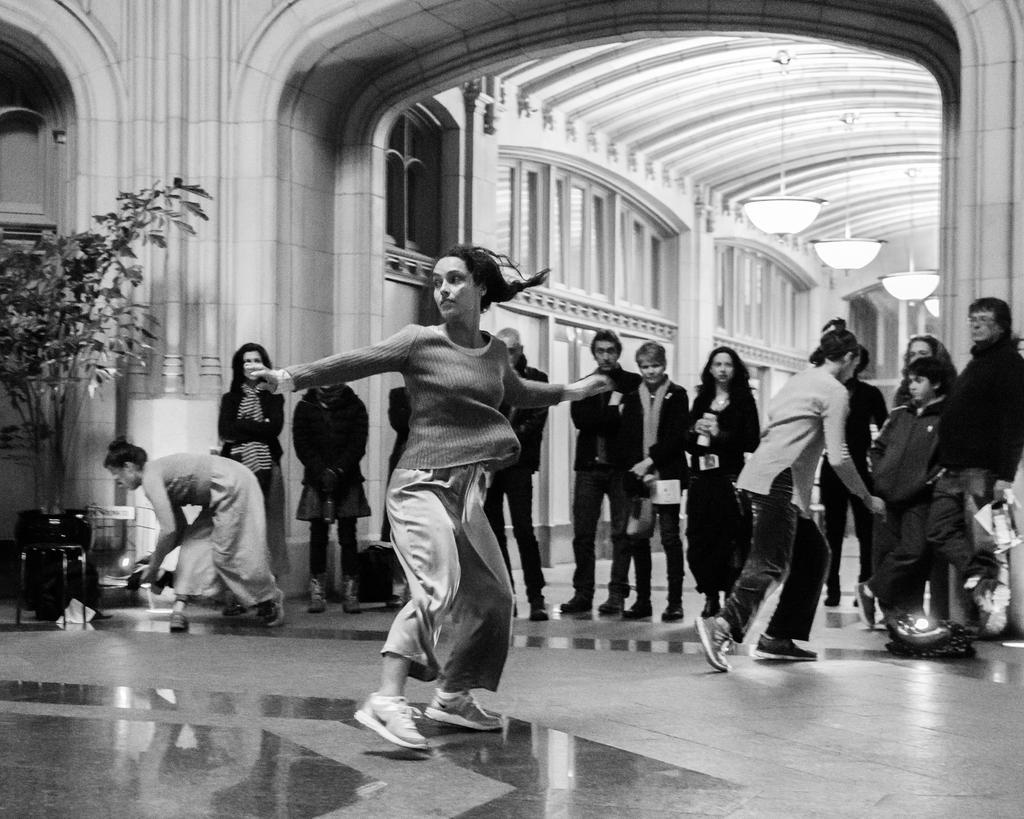How would you summarize this image in a sentence or two? In this image I can see a group of people. On the left side I can see a plant. At the top I can see the lights. I can also see the image is in black and white color. 